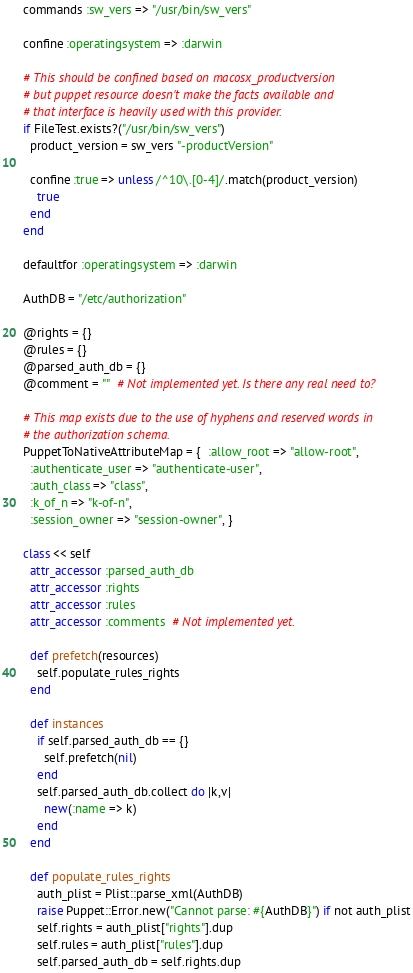Convert code to text. <code><loc_0><loc_0><loc_500><loc_500><_Ruby_>  commands :sw_vers => "/usr/bin/sw_vers"

  confine :operatingsystem => :darwin

  # This should be confined based on macosx_productversion
  # but puppet resource doesn't make the facts available and
  # that interface is heavily used with this provider.
  if FileTest.exists?("/usr/bin/sw_vers")
    product_version = sw_vers "-productVersion"

    confine :true => unless /^10\.[0-4]/.match(product_version)
      true
    end
  end

  defaultfor :operatingsystem => :darwin

  AuthDB = "/etc/authorization"

  @rights = {}
  @rules = {}
  @parsed_auth_db = {}
  @comment = ""  # Not implemented yet. Is there any real need to?

  # This map exists due to the use of hyphens and reserved words in
  # the authorization schema.
  PuppetToNativeAttributeMap = {  :allow_root => "allow-root",
    :authenticate_user => "authenticate-user",
    :auth_class => "class",
    :k_of_n => "k-of-n",
    :session_owner => "session-owner", }

  class << self
    attr_accessor :parsed_auth_db
    attr_accessor :rights
    attr_accessor :rules
    attr_accessor :comments  # Not implemented yet.

    def prefetch(resources)
      self.populate_rules_rights
    end

    def instances
      if self.parsed_auth_db == {}
        self.prefetch(nil)
      end
      self.parsed_auth_db.collect do |k,v|
        new(:name => k)
      end
    end

    def populate_rules_rights
      auth_plist = Plist::parse_xml(AuthDB)
      raise Puppet::Error.new("Cannot parse: #{AuthDB}") if not auth_plist
      self.rights = auth_plist["rights"].dup
      self.rules = auth_plist["rules"].dup
      self.parsed_auth_db = self.rights.dup</code> 